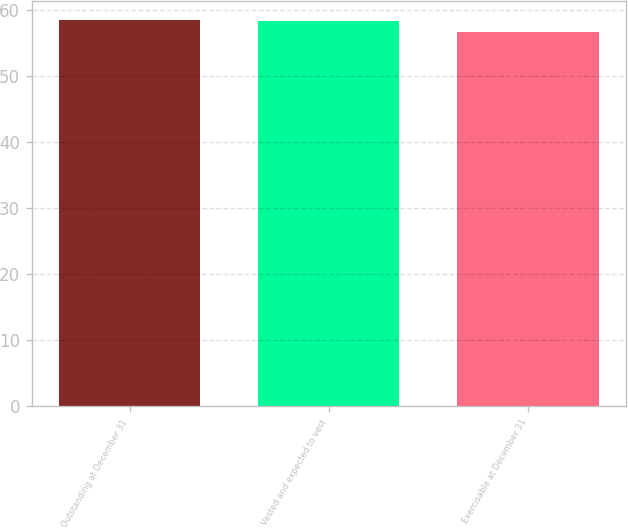Convert chart to OTSL. <chart><loc_0><loc_0><loc_500><loc_500><bar_chart><fcel>Outstanding at December 31<fcel>Vested and expected to vest<fcel>Exercisable at December 31<nl><fcel>58.44<fcel>58.27<fcel>56.65<nl></chart> 